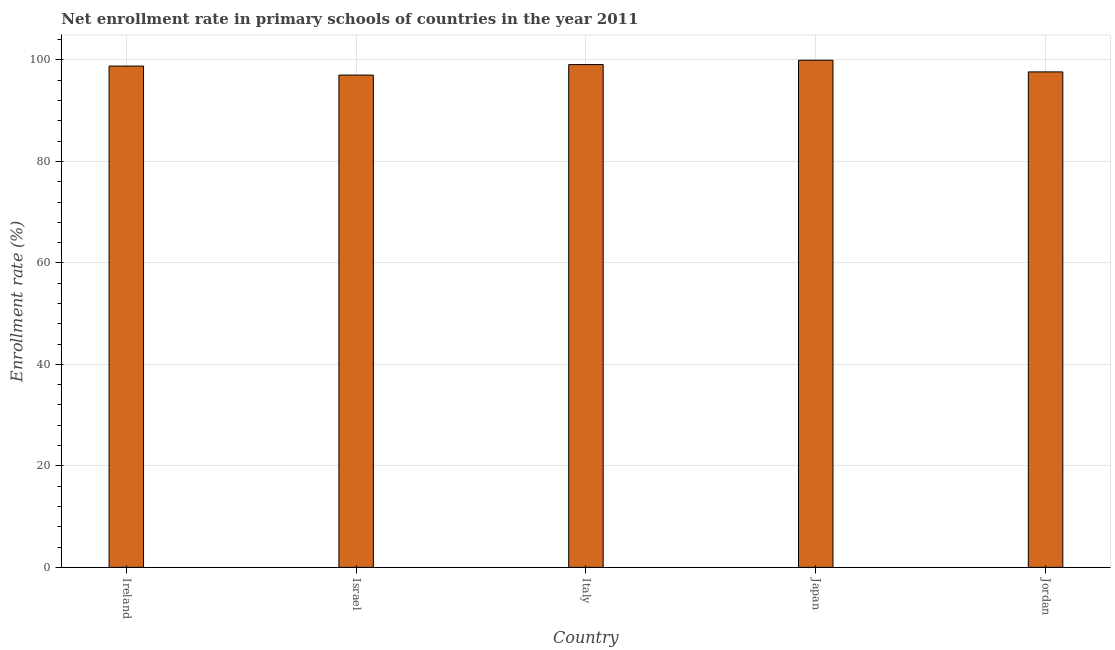Does the graph contain grids?
Your answer should be compact. Yes. What is the title of the graph?
Your answer should be compact. Net enrollment rate in primary schools of countries in the year 2011. What is the label or title of the Y-axis?
Give a very brief answer. Enrollment rate (%). What is the net enrollment rate in primary schools in Italy?
Offer a terse response. 99.1. Across all countries, what is the maximum net enrollment rate in primary schools?
Keep it short and to the point. 99.95. Across all countries, what is the minimum net enrollment rate in primary schools?
Provide a succinct answer. 97.02. In which country was the net enrollment rate in primary schools minimum?
Give a very brief answer. Israel. What is the sum of the net enrollment rate in primary schools?
Offer a terse response. 492.52. What is the difference between the net enrollment rate in primary schools in Israel and Jordan?
Ensure brevity in your answer.  -0.63. What is the average net enrollment rate in primary schools per country?
Provide a short and direct response. 98.5. What is the median net enrollment rate in primary schools?
Your answer should be compact. 98.8. In how many countries, is the net enrollment rate in primary schools greater than 4 %?
Your response must be concise. 5. What is the ratio of the net enrollment rate in primary schools in Israel to that in Jordan?
Make the answer very short. 0.99. What is the difference between the highest and the second highest net enrollment rate in primary schools?
Your answer should be compact. 0.85. What is the difference between the highest and the lowest net enrollment rate in primary schools?
Give a very brief answer. 2.93. In how many countries, is the net enrollment rate in primary schools greater than the average net enrollment rate in primary schools taken over all countries?
Keep it short and to the point. 3. Are all the bars in the graph horizontal?
Provide a short and direct response. No. How many countries are there in the graph?
Give a very brief answer. 5. What is the Enrollment rate (%) of Ireland?
Your response must be concise. 98.8. What is the Enrollment rate (%) in Israel?
Offer a very short reply. 97.02. What is the Enrollment rate (%) in Italy?
Your response must be concise. 99.1. What is the Enrollment rate (%) of Japan?
Offer a terse response. 99.95. What is the Enrollment rate (%) in Jordan?
Give a very brief answer. 97.65. What is the difference between the Enrollment rate (%) in Ireland and Israel?
Your answer should be very brief. 1.78. What is the difference between the Enrollment rate (%) in Ireland and Italy?
Make the answer very short. -0.29. What is the difference between the Enrollment rate (%) in Ireland and Japan?
Keep it short and to the point. -1.15. What is the difference between the Enrollment rate (%) in Ireland and Jordan?
Ensure brevity in your answer.  1.15. What is the difference between the Enrollment rate (%) in Israel and Italy?
Your response must be concise. -2.07. What is the difference between the Enrollment rate (%) in Israel and Japan?
Your response must be concise. -2.93. What is the difference between the Enrollment rate (%) in Israel and Jordan?
Your answer should be very brief. -0.63. What is the difference between the Enrollment rate (%) in Italy and Japan?
Provide a short and direct response. -0.85. What is the difference between the Enrollment rate (%) in Italy and Jordan?
Offer a terse response. 1.45. What is the difference between the Enrollment rate (%) in Japan and Jordan?
Make the answer very short. 2.3. What is the ratio of the Enrollment rate (%) in Ireland to that in Israel?
Keep it short and to the point. 1.02. What is the ratio of the Enrollment rate (%) in Ireland to that in Italy?
Offer a very short reply. 1. What is the ratio of the Enrollment rate (%) in Ireland to that in Japan?
Make the answer very short. 0.99. What is the ratio of the Enrollment rate (%) in Ireland to that in Jordan?
Keep it short and to the point. 1.01. What is the ratio of the Enrollment rate (%) in Israel to that in Italy?
Offer a very short reply. 0.98. What is the ratio of the Enrollment rate (%) in Italy to that in Japan?
Ensure brevity in your answer.  0.99. 